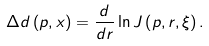Convert formula to latex. <formula><loc_0><loc_0><loc_500><loc_500>\Delta d \left ( p , x \right ) = \frac { d } { d r } \ln J \left ( p , r , \xi \right ) .</formula> 